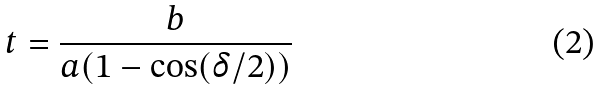<formula> <loc_0><loc_0><loc_500><loc_500>t = \frac { b } { a ( 1 - \cos ( \delta / 2 ) ) }</formula> 